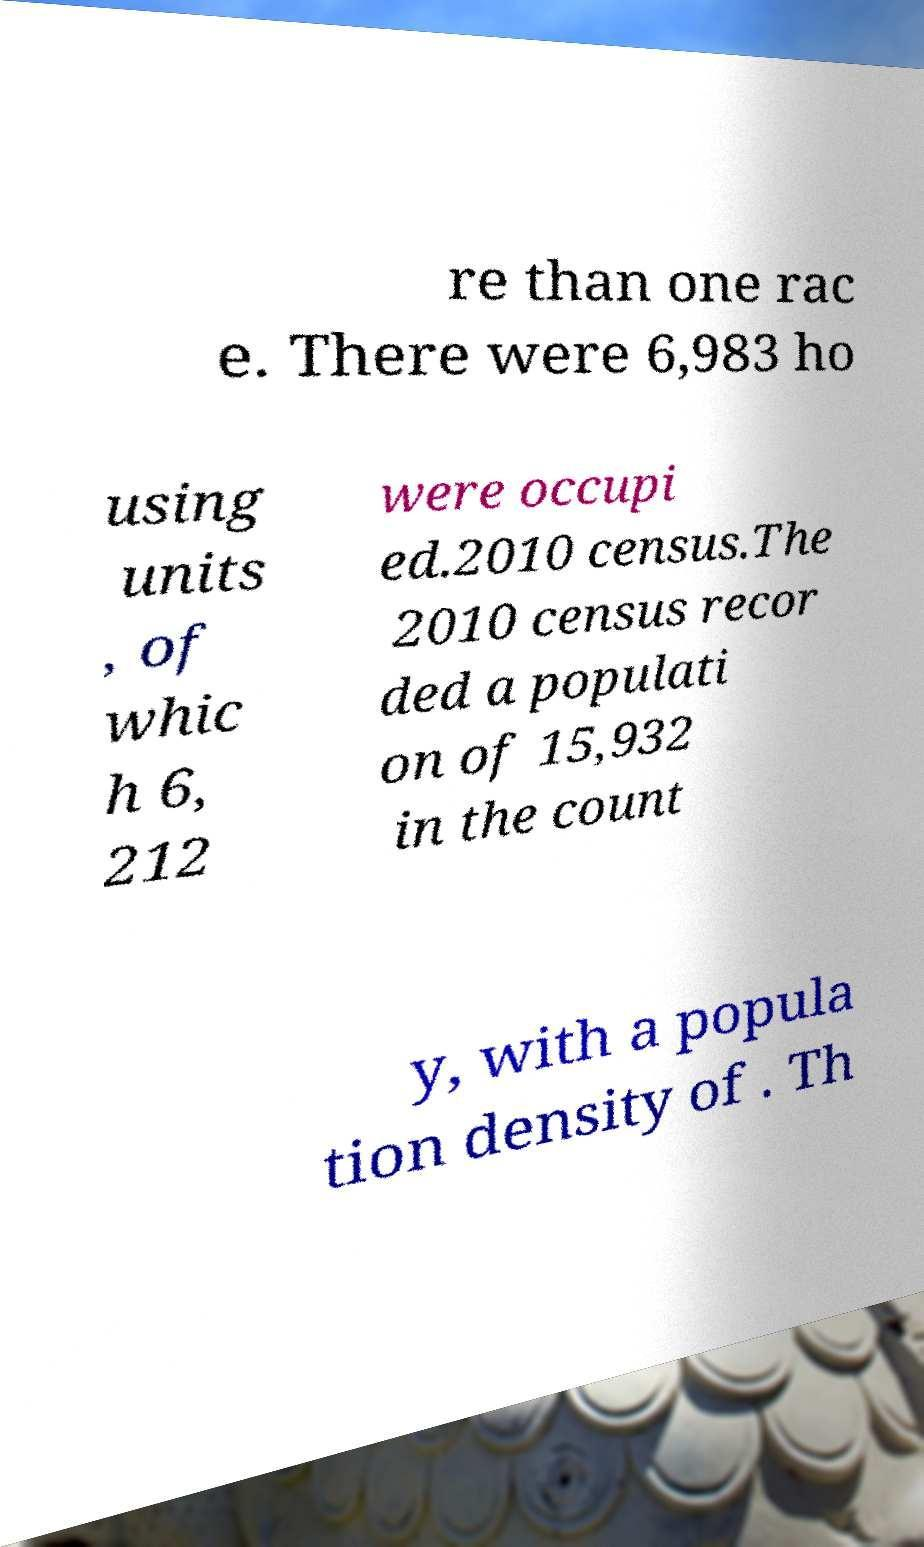Can you read and provide the text displayed in the image?This photo seems to have some interesting text. Can you extract and type it out for me? re than one rac e. There were 6,983 ho using units , of whic h 6, 212 were occupi ed.2010 census.The 2010 census recor ded a populati on of 15,932 in the count y, with a popula tion density of . Th 